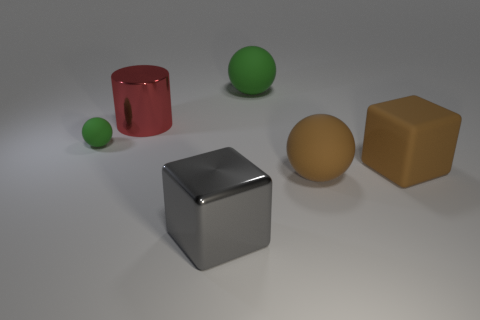What material is the big object that is to the right of the rubber ball that is on the right side of the green thing on the right side of the big red object? rubber 